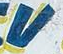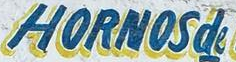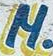Read the text content from these images in order, separated by a semicolon. V; HORNOSde; M 